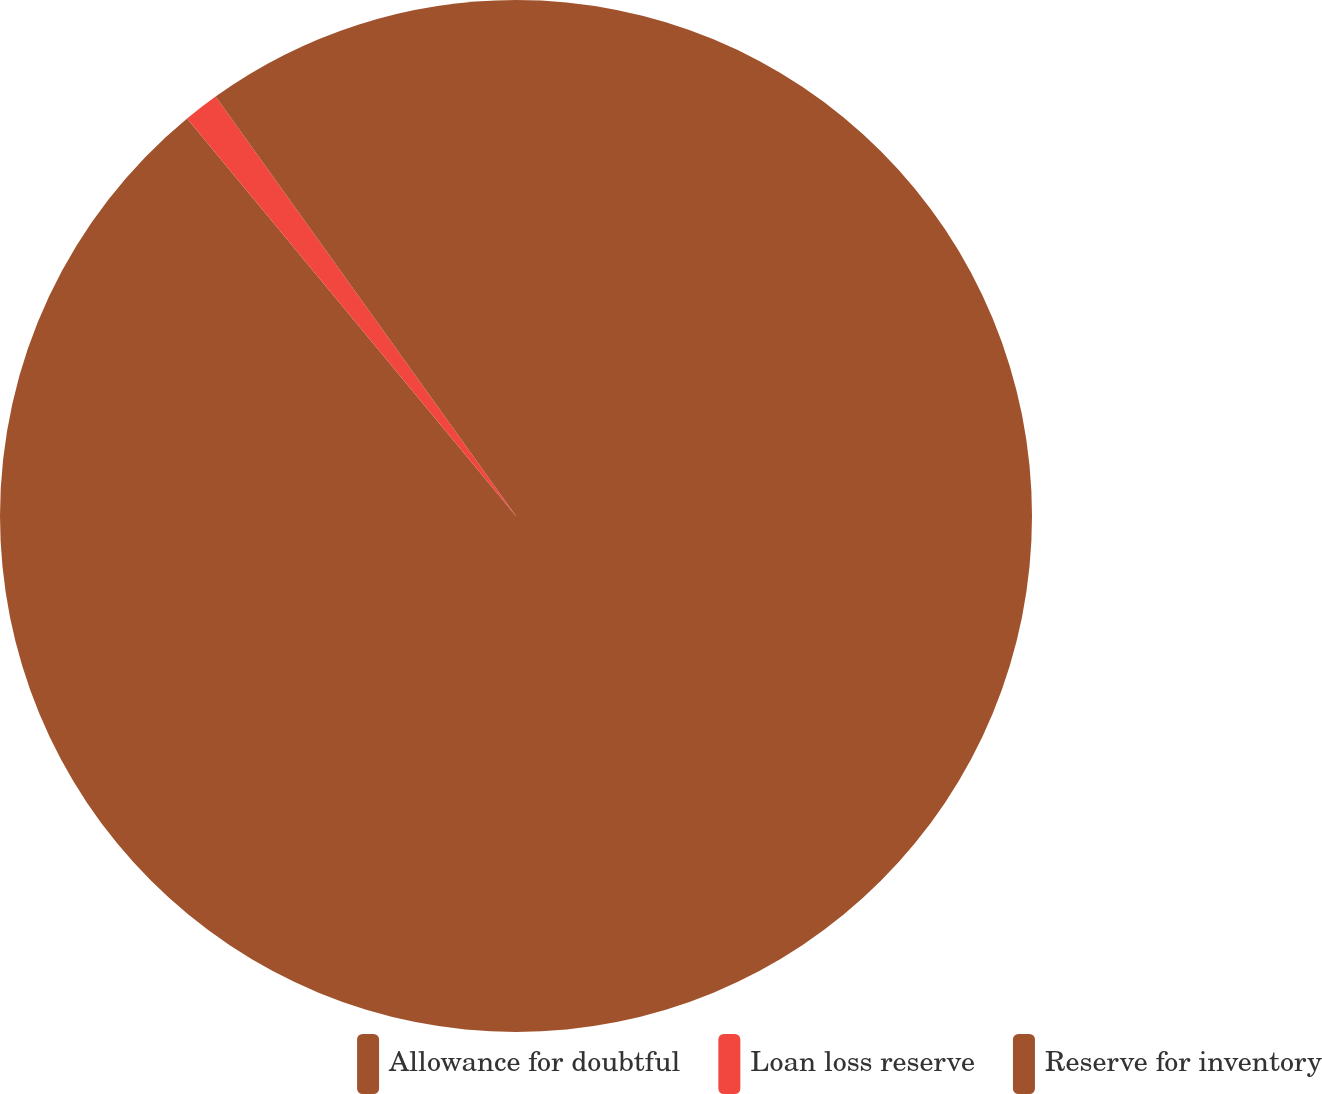Convert chart. <chart><loc_0><loc_0><loc_500><loc_500><pie_chart><fcel>Allowance for doubtful<fcel>Loan loss reserve<fcel>Reserve for inventory<nl><fcel>89.0%<fcel>1.11%<fcel>9.89%<nl></chart> 